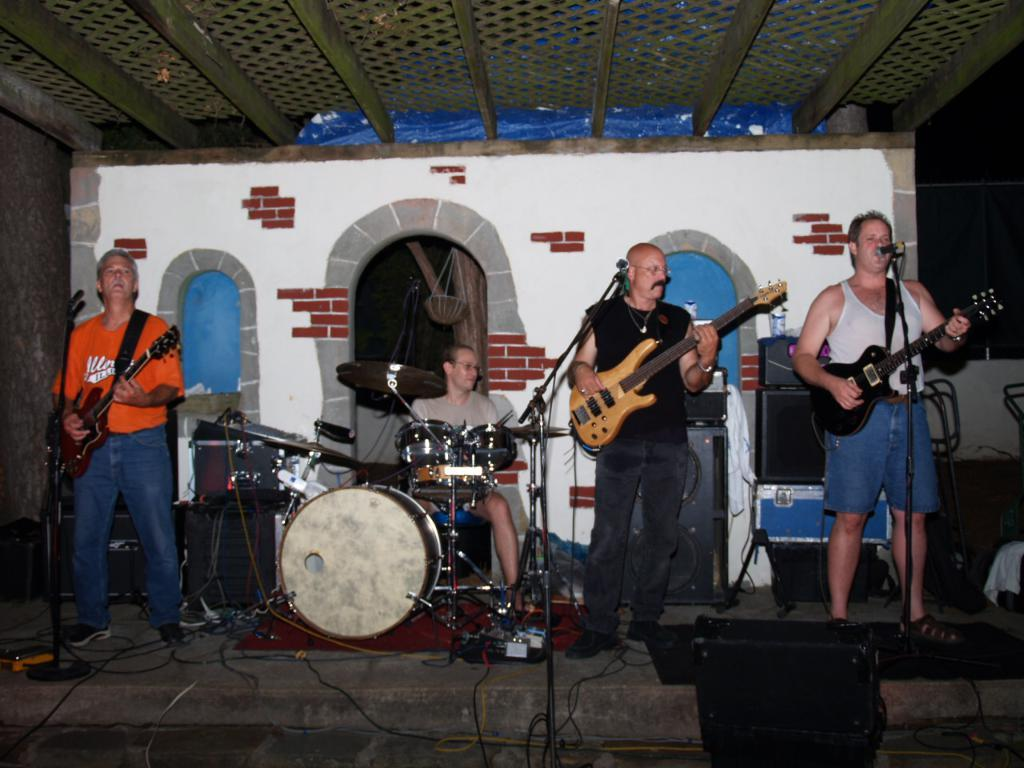How many musicians are in the image? There are three musicians in the image. What are the musicians holding? Each musician is holding a guitar. What is in front of the musicians? There is a microphone in front of the musicians. Which musician is actively playing their instrument? One person is playing a musical instrument. What type of ship can be seen in the background of the image? There is no ship present in the image; it features three musicians holding guitars and a microphone. 